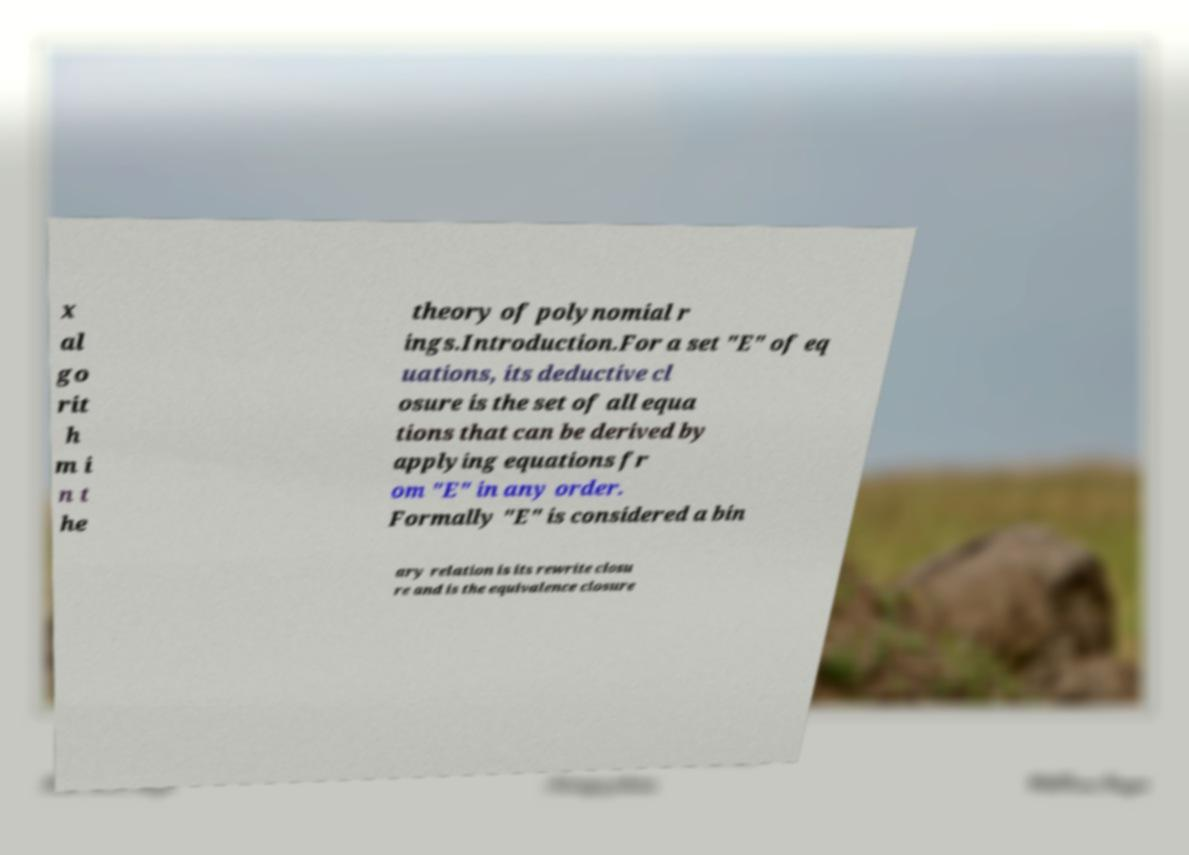Can you accurately transcribe the text from the provided image for me? x al go rit h m i n t he theory of polynomial r ings.Introduction.For a set "E" of eq uations, its deductive cl osure is the set of all equa tions that can be derived by applying equations fr om "E" in any order. Formally "E" is considered a bin ary relation is its rewrite closu re and is the equivalence closure 